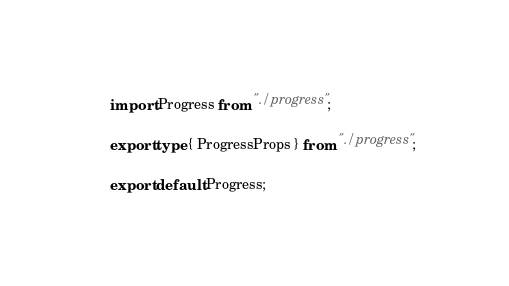Convert code to text. <code><loc_0><loc_0><loc_500><loc_500><_TypeScript_>import Progress from "./progress";

export type { ProgressProps } from "./progress";

export default Progress;
</code> 